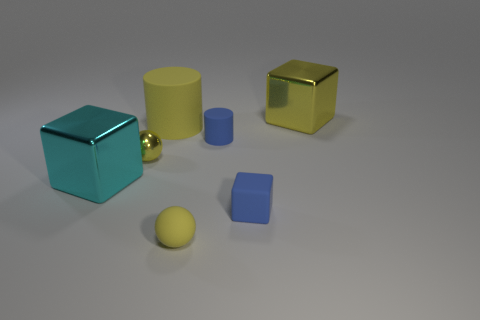Is the cyan cube made of the same material as the tiny cylinder?
Give a very brief answer. No. There is a yellow thing that is the same size as the yellow cylinder; what shape is it?
Offer a terse response. Cube. Are there more large yellow blocks than tiny brown metallic cylinders?
Your answer should be very brief. Yes. What is the large object that is both left of the matte sphere and behind the yellow metal sphere made of?
Offer a terse response. Rubber. What number of other objects are the same material as the cyan cube?
Ensure brevity in your answer.  2. How many shiny cubes have the same color as the big rubber thing?
Provide a short and direct response. 1. What size is the yellow matte thing that is in front of the blue object behind the big metal thing in front of the blue cylinder?
Offer a terse response. Small. How many metallic things are either large blocks or small yellow things?
Your answer should be compact. 3. There is a large rubber thing; is it the same shape as the yellow metal object that is to the left of the tiny yellow matte object?
Your response must be concise. No. Is the number of big yellow rubber cylinders that are in front of the large yellow cylinder greater than the number of tiny cubes to the left of the cyan metal thing?
Offer a terse response. No. 